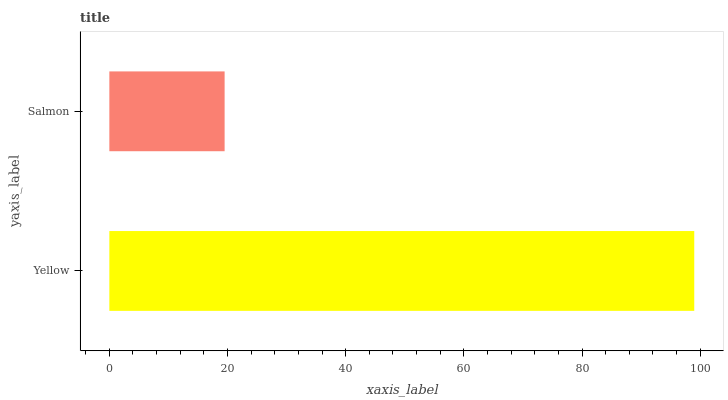Is Salmon the minimum?
Answer yes or no. Yes. Is Yellow the maximum?
Answer yes or no. Yes. Is Salmon the maximum?
Answer yes or no. No. Is Yellow greater than Salmon?
Answer yes or no. Yes. Is Salmon less than Yellow?
Answer yes or no. Yes. Is Salmon greater than Yellow?
Answer yes or no. No. Is Yellow less than Salmon?
Answer yes or no. No. Is Yellow the high median?
Answer yes or no. Yes. Is Salmon the low median?
Answer yes or no. Yes. Is Salmon the high median?
Answer yes or no. No. Is Yellow the low median?
Answer yes or no. No. 